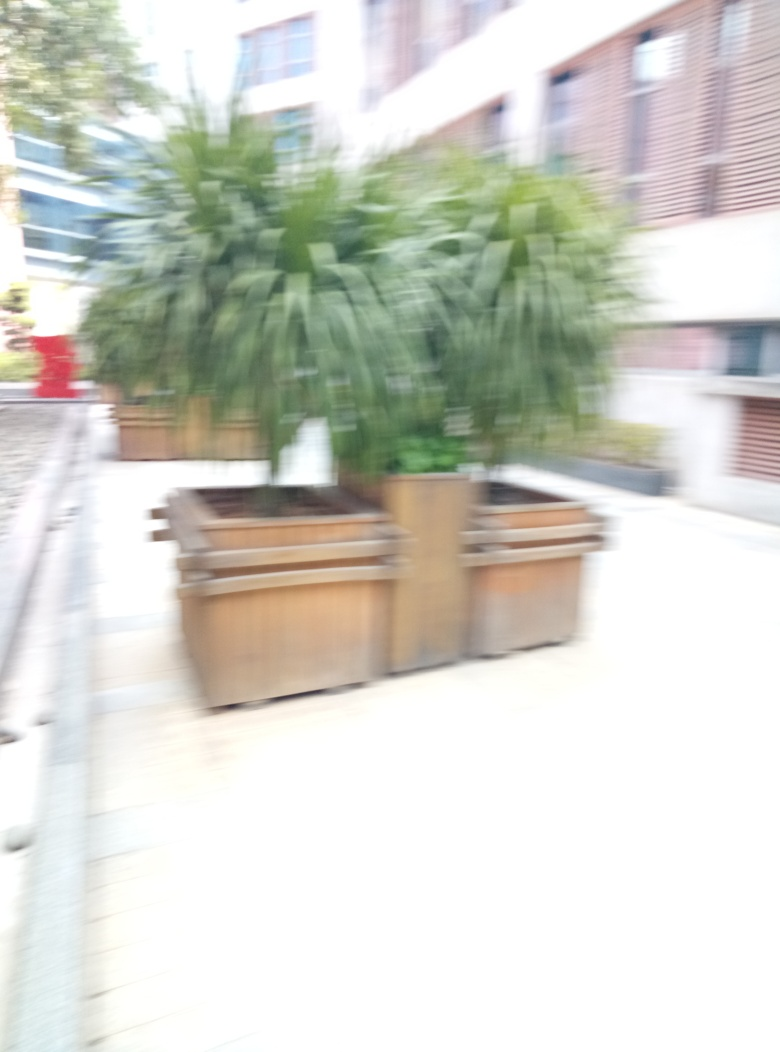Could the blur in the photo be artistically intentional? While artistic blur is used to convey motion or emphasize certain parts of a photo, in this instance, the uniform blur across the entire image more likely indicates a technical mishap rather than a deliberate artistic choice. 